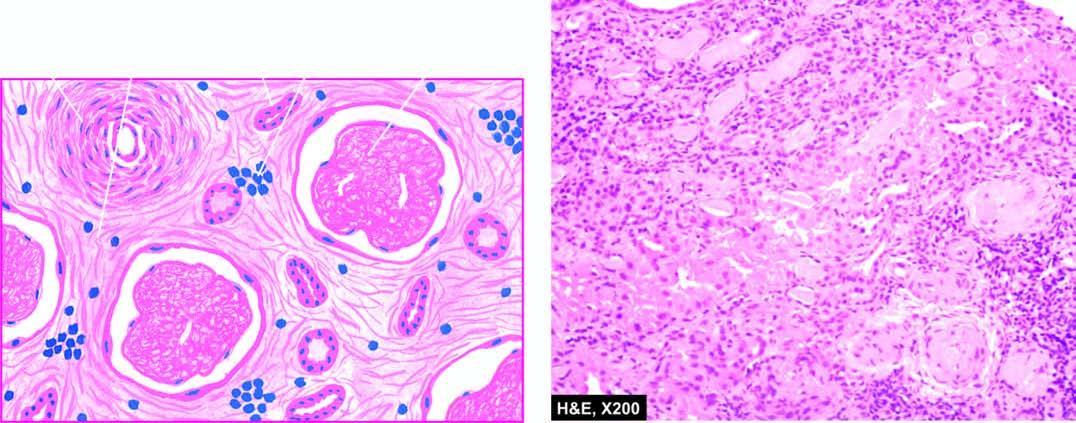re blood vessels in the interstitium hyalinised and thickened while the interstitium shows fine fibrosis and a few chronic inflammatory cells?
Answer the question using a single word or phrase. Yes 